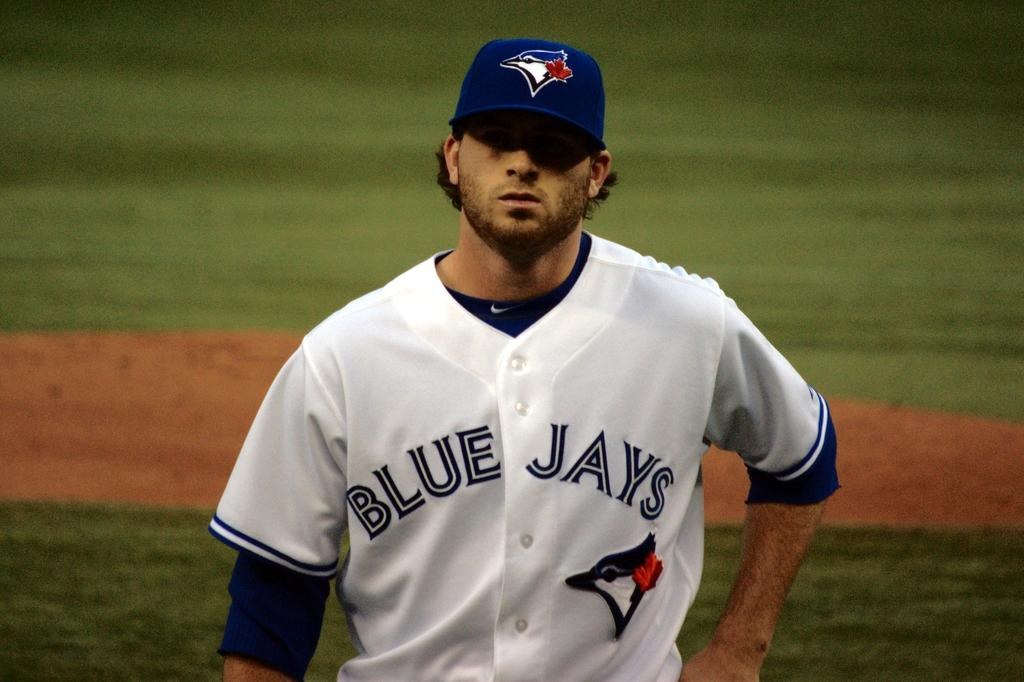<image>
Provide a brief description of the given image. a blue jays player that has a hat on 